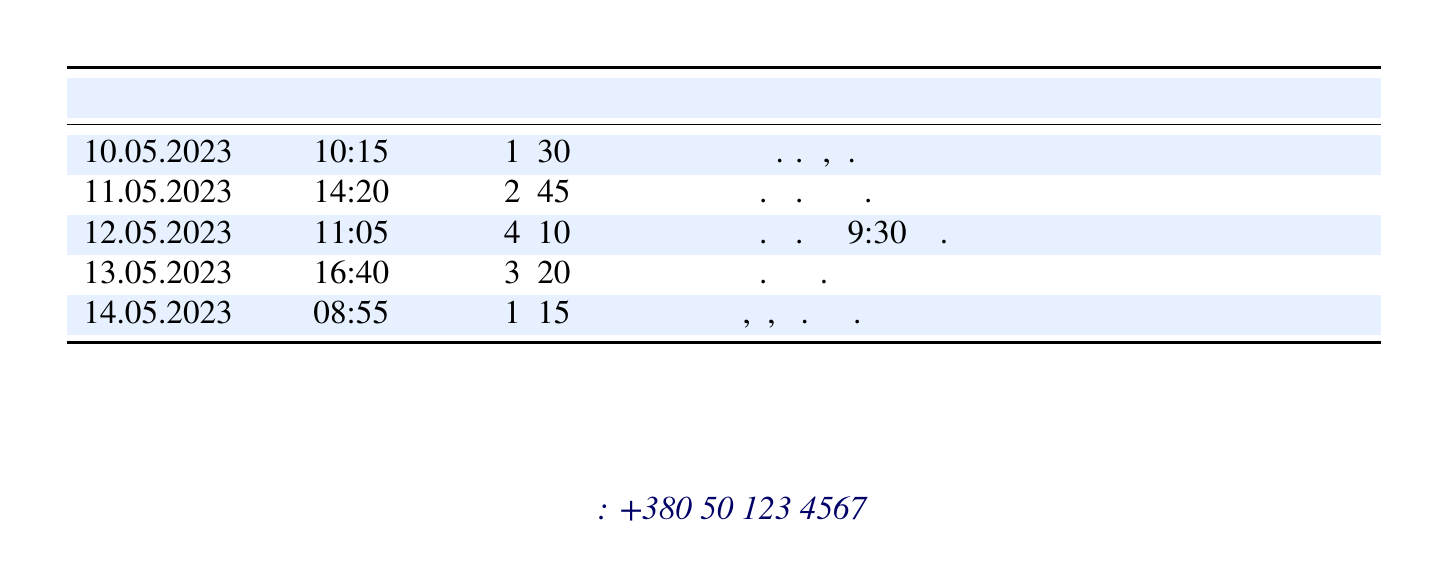what is the date of the first call? The first call is recorded on the 10th of May 2023.
Answer: 10.05.2023 what time was the call on 11th May? The call on 11th May took place at 14:20.
Answer: 14:20 how long did the call on 12th May last? The duration of the call on 12th May was 4 minutes and 10 seconds.
Answer: 4 хв 10 сек who is the person being called? The records indicate the person being called is Олена.
Answer: Олена what did Олена mention during the call on 11th May? Олена mentioned the sermon by отець Сергій on Sunday.
Answer: проповідь отця Сергія what was confirmed during the call on 13th May? The plans for visiting the church were confirmed during the call.
Answer: Плани на відвідування церкви what was the purpose of the quick call on 14th May? The purpose was to ensure Олена woke up and confirmed the meeting time.
Answer: Переконатися, що Олена прокинулася what is the phone number of Олена? The document provides Олена's phone number as +380 50 123 4567.
Answer: +380 50 123 4567 